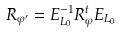<formula> <loc_0><loc_0><loc_500><loc_500>R _ { \varphi ^ { \prime } } = E _ { L _ { 0 } } ^ { - 1 } R ^ { t } _ { \varphi } E _ { L _ { 0 } }</formula> 